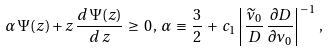Convert formula to latex. <formula><loc_0><loc_0><loc_500><loc_500>\alpha \, \Psi ( z ) + z \, \frac { d \, \Psi ( z ) } { d \, z } \, \geq \, 0 \, , \, \alpha \, \equiv \, \frac { 3 } { 2 } \, + \, c _ { 1 } \left | \, \frac { \widetilde { \nu } _ { 0 } } { D } \, \frac { \partial D } { \partial \nu _ { 0 } } \right | ^ { - \, 1 } \, ,</formula> 